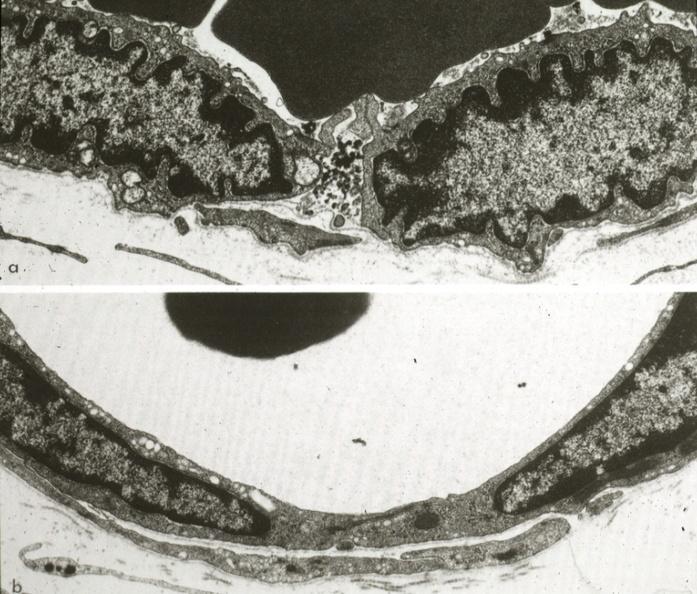does fat necrosis show continuous type illustrating opened and closed intercellular junction?
Answer the question using a single word or phrase. No 